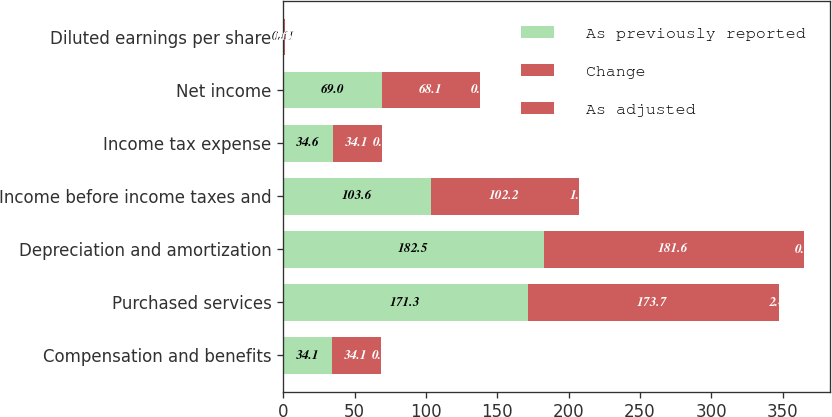Convert chart to OTSL. <chart><loc_0><loc_0><loc_500><loc_500><stacked_bar_chart><ecel><fcel>Compensation and benefits<fcel>Purchased services<fcel>Depreciation and amortization<fcel>Income before income taxes and<fcel>Income tax expense<fcel>Net income<fcel>Diluted earnings per share<nl><fcel>As previously reported<fcel>34.1<fcel>171.3<fcel>182.5<fcel>103.6<fcel>34.6<fcel>69<fcel>0.61<nl><fcel>Change<fcel>34.1<fcel>173.7<fcel>181.6<fcel>102.2<fcel>34.1<fcel>68.1<fcel>0.6<nl><fcel>As adjusted<fcel>0.1<fcel>2.4<fcel>0.9<fcel>1.4<fcel>0.5<fcel>0.9<fcel>0.01<nl></chart> 